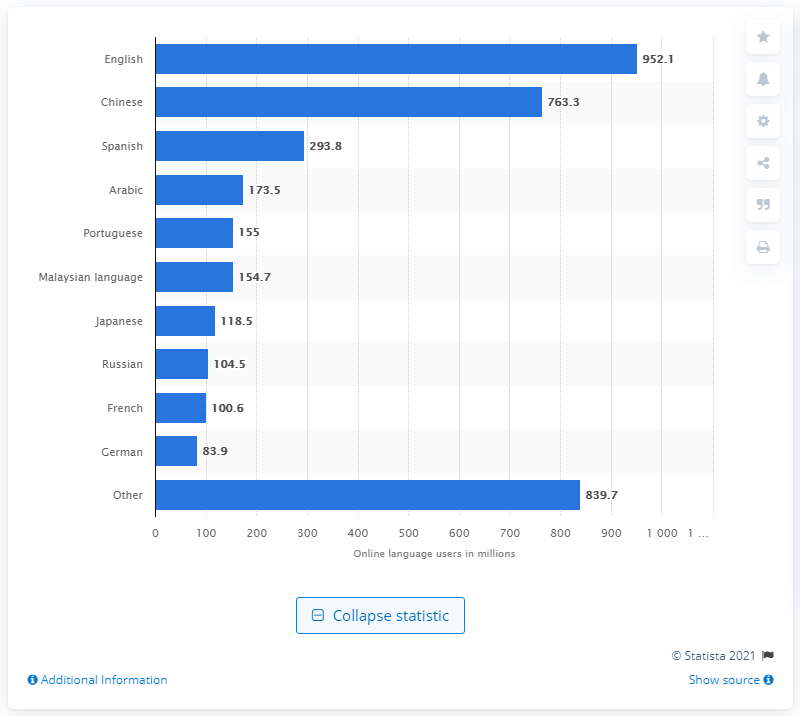How can this data influence global digital marketing strategies? This data can greatly influence global digital marketing strategies by indicating which languages hold the most potential reach and engagement in online platforms. For instance, prioritizing content localization and customized marketing campaigns in English, Chinese, and Spanish could leverage their vast user bases to maximize impact and ROI. Could this linguistic data influence educational or technological developments? Absolutely, knowing which languages are most used online can guide the development of educational resources, apps, and technology to cater to these diverse linguistic groups. It encourages the creation of multilingual platforms and educational tools that can make learning and technology access more inclusive globally. 